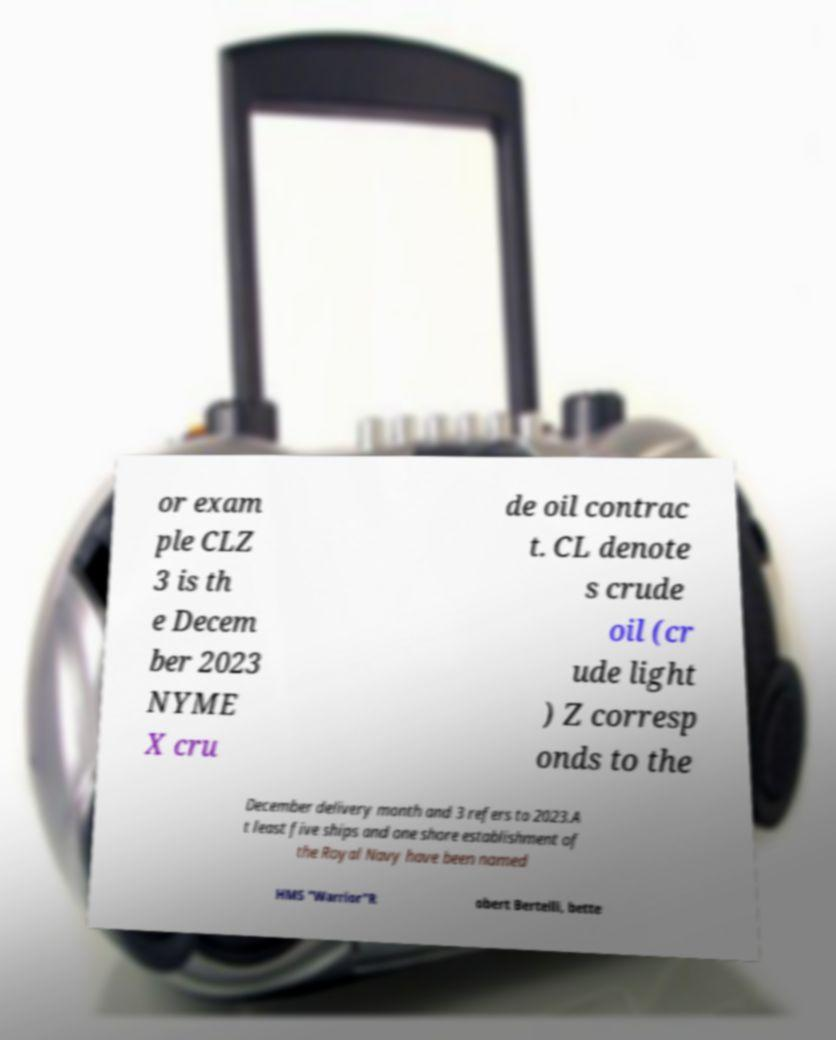What messages or text are displayed in this image? I need them in a readable, typed format. or exam ple CLZ 3 is th e Decem ber 2023 NYME X cru de oil contrac t. CL denote s crude oil (cr ude light ) Z corresp onds to the December delivery month and 3 refers to 2023.A t least five ships and one shore establishment of the Royal Navy have been named HMS "Warrior"R obert Bertelli, bette 